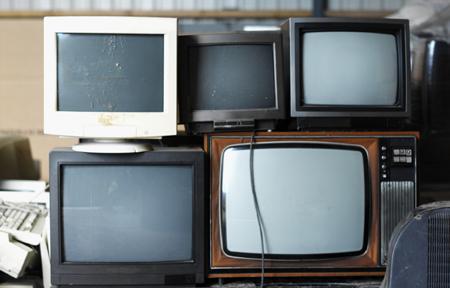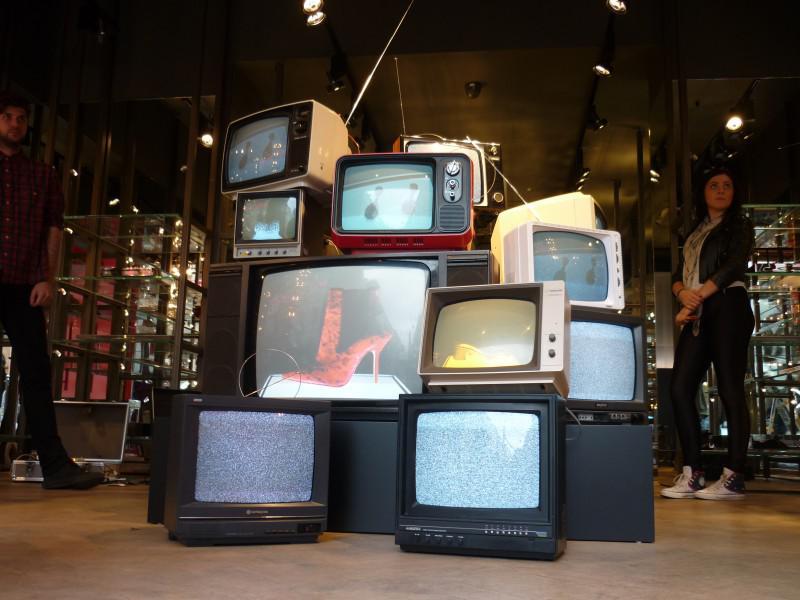The first image is the image on the left, the second image is the image on the right. Examine the images to the left and right. Is the description "In one image, an arrangement of old televisions that are turned on to various channels is stacked at least three high, while a second image shows exactly five television or computer screens." accurate? Answer yes or no. Yes. 